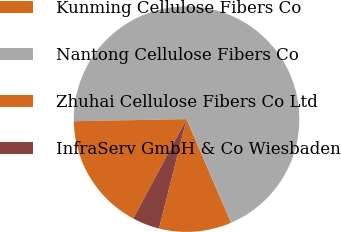Convert chart to OTSL. <chart><loc_0><loc_0><loc_500><loc_500><pie_chart><fcel>Kunming Cellulose Fibers Co<fcel>Nantong Cellulose Fibers Co<fcel>Zhuhai Cellulose Fibers Co Ltd<fcel>InfraServ GmbH & Co Wiesbaden<nl><fcel>10.39%<fcel>68.83%<fcel>16.88%<fcel>3.9%<nl></chart> 